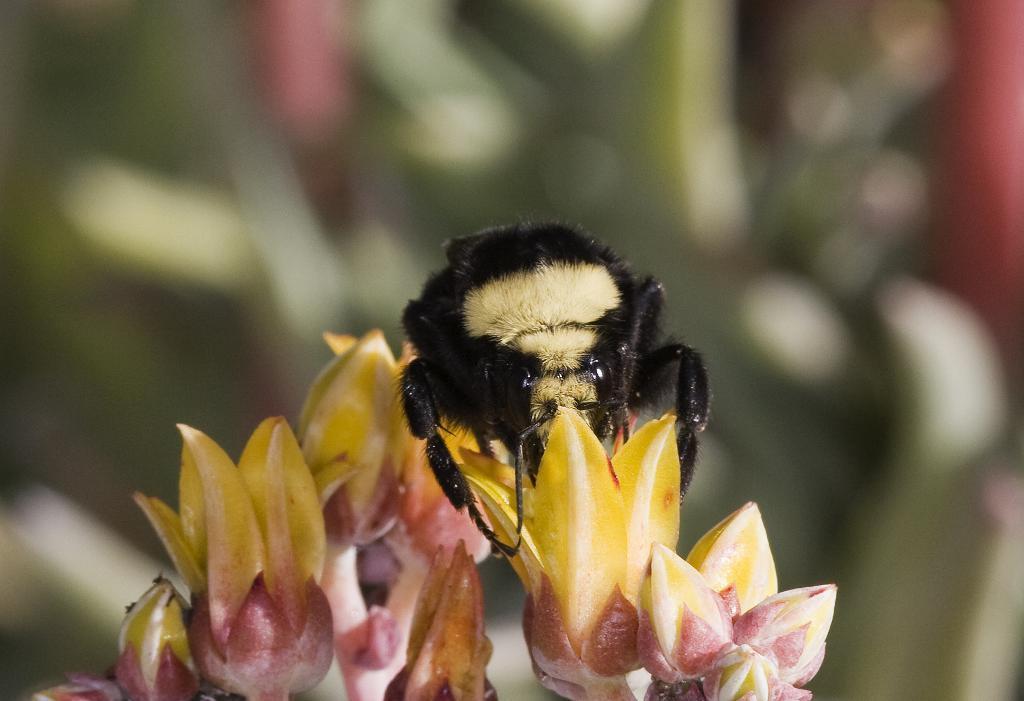Please provide a concise description of this image. In this image we can see flowers, buds, and an insect on a flower. There is a blur background. 